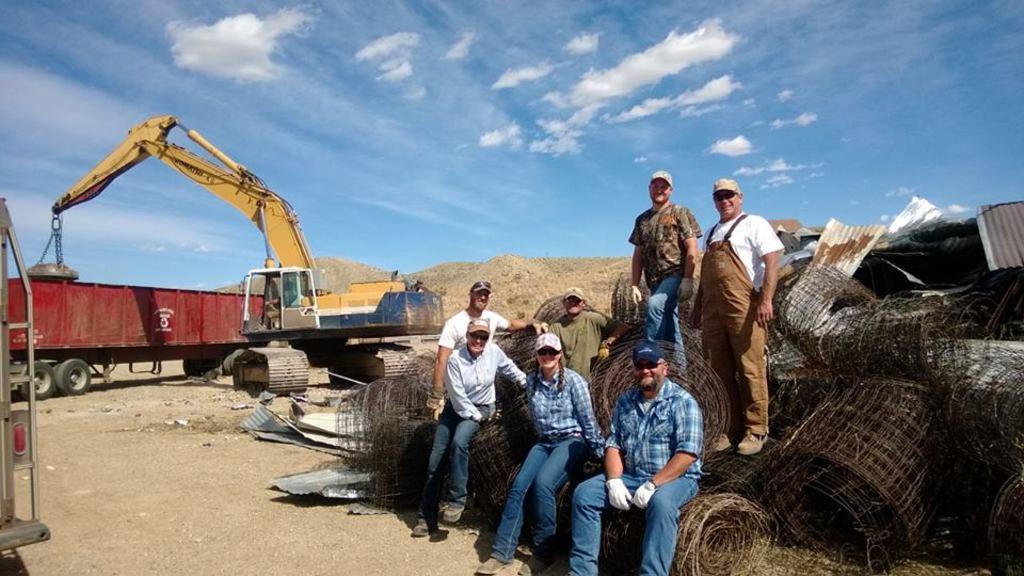Describe this image in one or two sentences. In this picture we can see four persons standing and three persons sitting here, on the left side there is a crane and a truck here, in the background there is the sky, we can see some sheets here. 